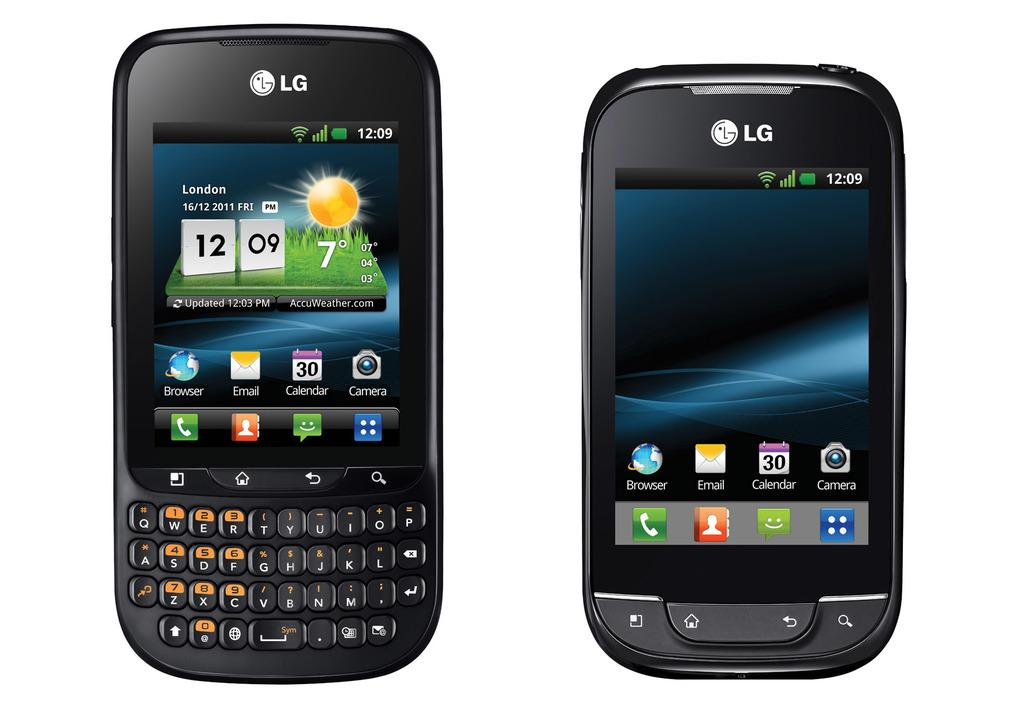Provide a one-sentence caption for the provided image. 16/12/2011 London is displayed on this LG smart phone. 